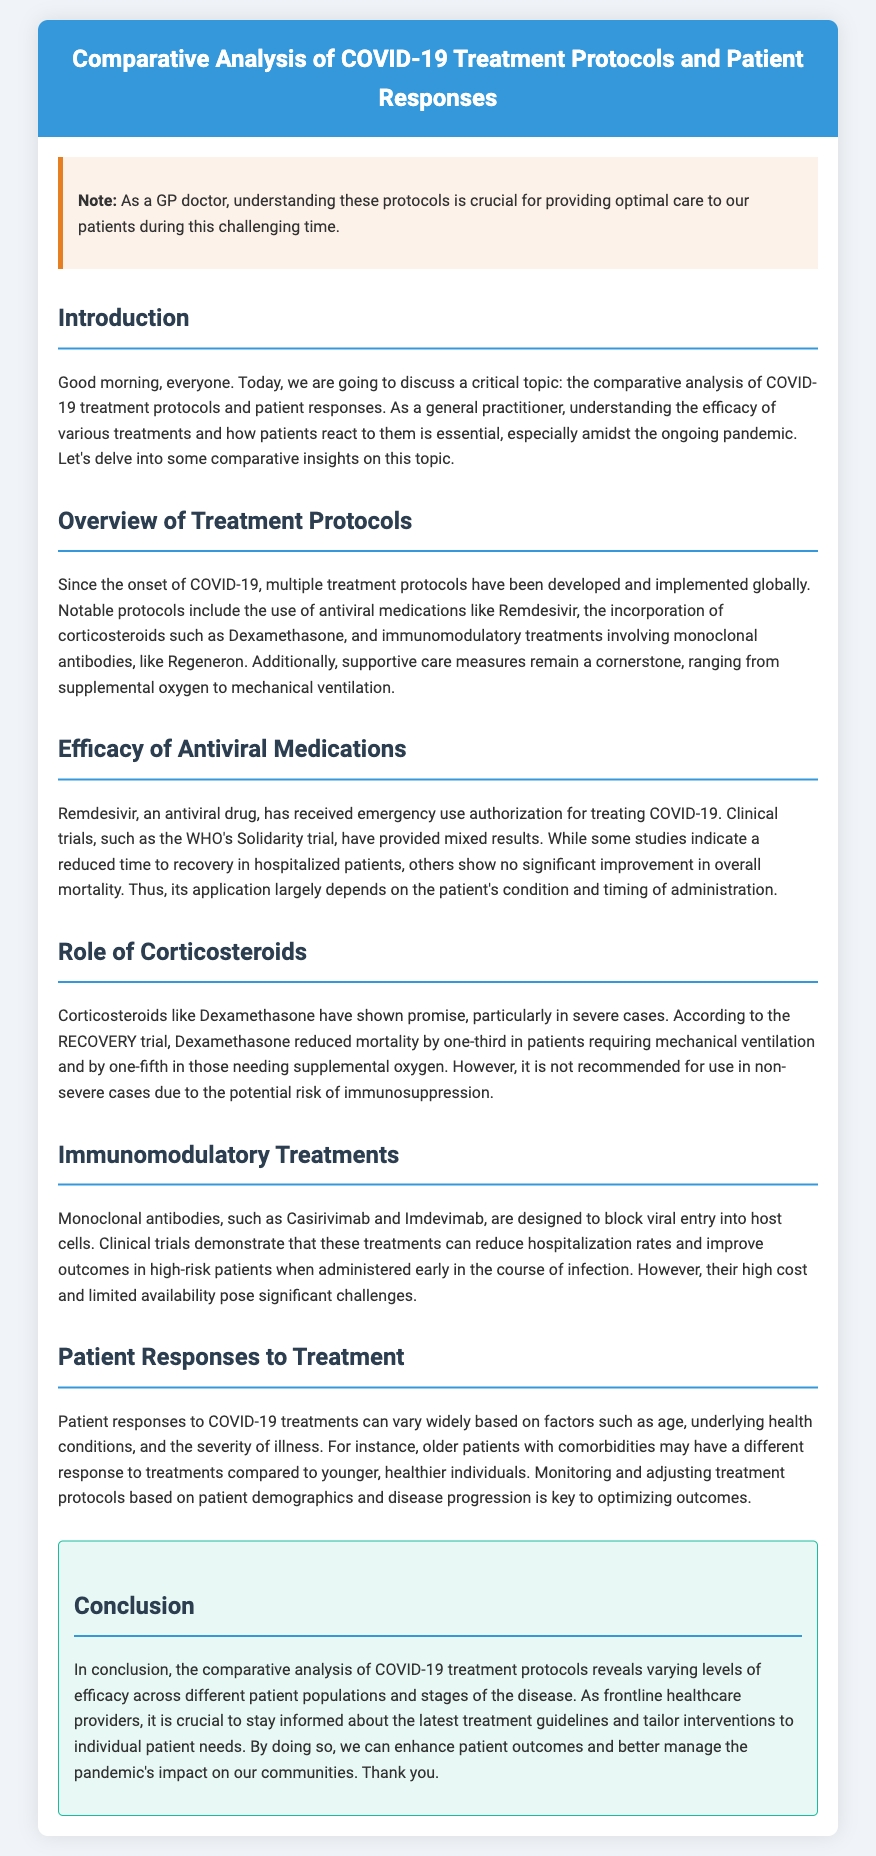What is the title of the document? The title provides the main topic of the document, which is about treatment protocols and patient responses during COVID-19.
Answer: Comparative Analysis of COVID-19 Treatment Protocols and Patient Responses Which antiviral medication received emergency use authorization? This information is found in the section regarding the efficacy of antiviral medications, highlighting a specific drug authorized for treatment.
Answer: Remdesivir What is the effect of Dexamethasone on mortality? The impact of Dexamethasone is discussed in relation to its efficacy in severe cases as outlined in the RECOVERY trial.
Answer: Reduced mortality by one-third What are monoclonal antibodies designed to block? This question addresses the function of monoclonal antibodies as described in the section about immunomodulatory treatments.
Answer: Viral entry into host cells Which factor can affect patient responses to treatment? This refers to the patient demographics discussed in the patient responses section, illustrating the variability in treatment effectiveness.
Answer: Age What is a recommended treatment for severe COVID-19 cases? This involves recognizing the protocol recommended based on clinical evidence from trials mentioned in the document.
Answer: Dexamethasone What does the document suggest is crucial for optimizing patient outcomes? This question addresses the overarching message outlined in the conclusion about tailoring interventions for individual patients.
Answer: Monitoring and adjusting treatment protocols How many treatment protocols are mentioned in the overview? This asks for a quick count based on the overview section's content discussing different treatments.
Answer: Three 